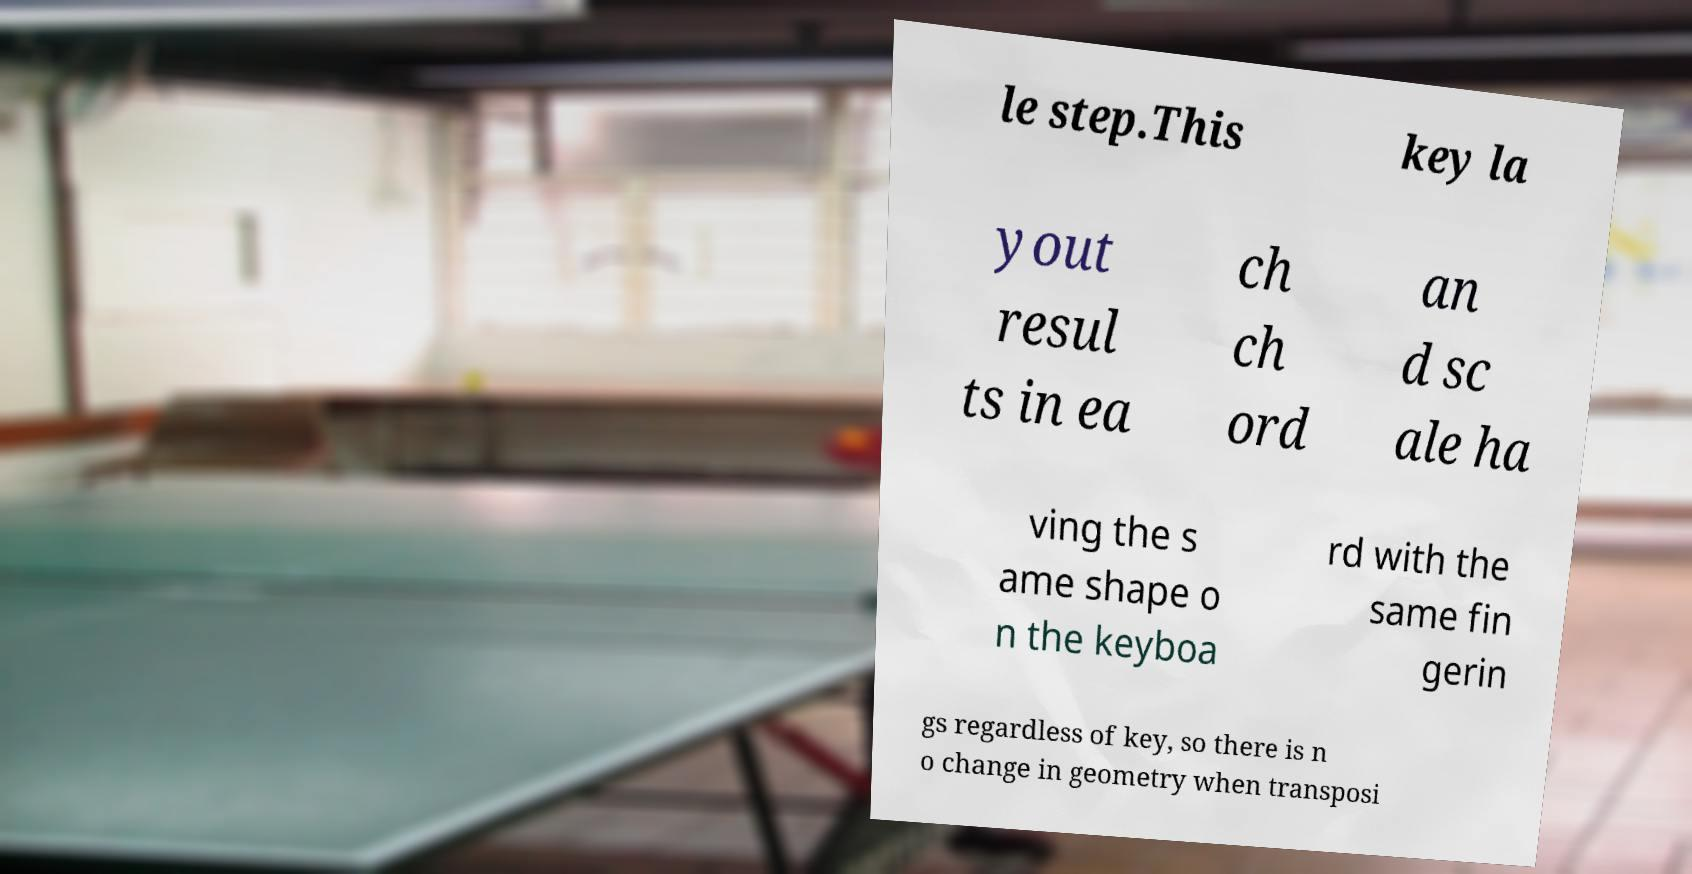For documentation purposes, I need the text within this image transcribed. Could you provide that? le step.This key la yout resul ts in ea ch ch ord an d sc ale ha ving the s ame shape o n the keyboa rd with the same fin gerin gs regardless of key, so there is n o change in geometry when transposi 